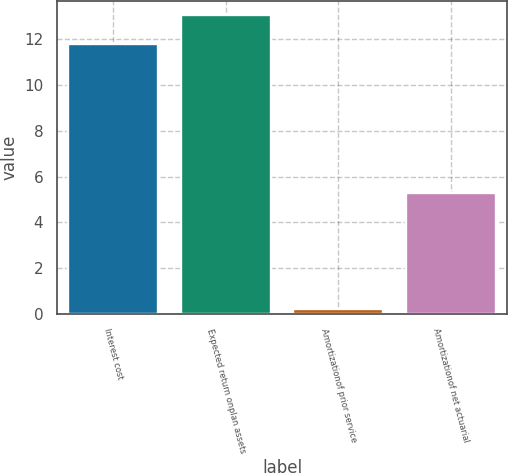Convert chart. <chart><loc_0><loc_0><loc_500><loc_500><bar_chart><fcel>Interest cost<fcel>Expected return onplan assets<fcel>Amortizationof prior service<fcel>Amortizationof net actuarial<nl><fcel>11.8<fcel>13.05<fcel>0.2<fcel>5.3<nl></chart> 